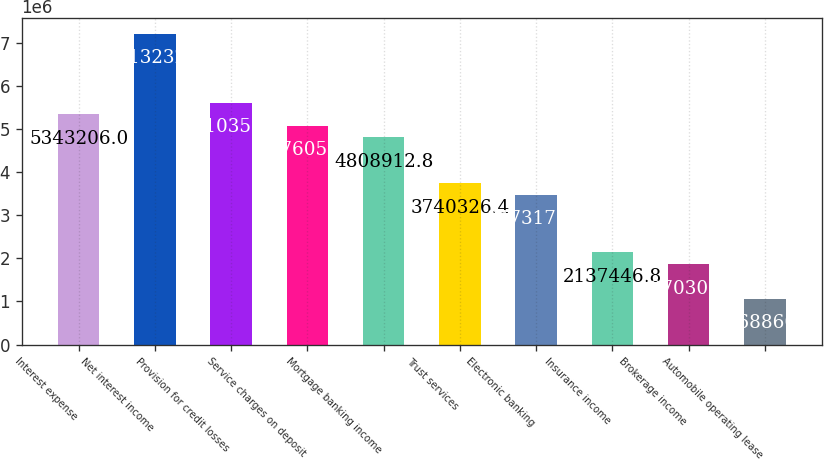<chart> <loc_0><loc_0><loc_500><loc_500><bar_chart><fcel>Interest expense<fcel>Net interest income<fcel>Provision for credit losses<fcel>Service charges on deposit<fcel>Mortgage banking income<fcel>Trust services<fcel>Electronic banking<fcel>Insurance income<fcel>Brokerage income<fcel>Automobile operating lease<nl><fcel>5.34321e+06<fcel>7.21323e+06<fcel>5.61035e+06<fcel>5.07606e+06<fcel>4.80891e+06<fcel>3.74033e+06<fcel>3.47318e+06<fcel>2.13745e+06<fcel>1.8703e+06<fcel>1.06886e+06<nl></chart> 